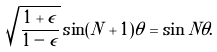Convert formula to latex. <formula><loc_0><loc_0><loc_500><loc_500>\sqrt { \frac { 1 + \epsilon } { 1 - \epsilon } } \sin ( N + 1 ) \theta = \sin N \theta .</formula> 